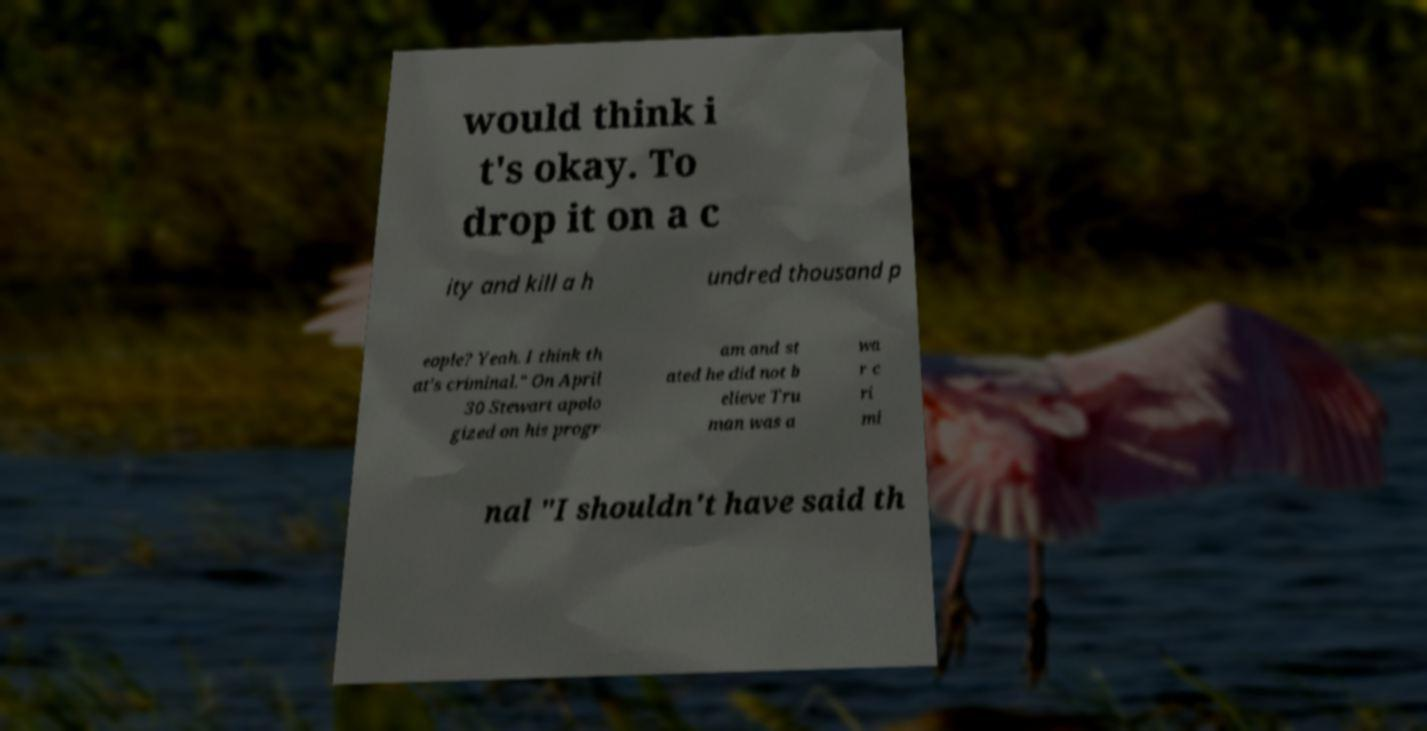Please identify and transcribe the text found in this image. would think i t's okay. To drop it on a c ity and kill a h undred thousand p eople? Yeah. I think th at's criminal." On April 30 Stewart apolo gized on his progr am and st ated he did not b elieve Tru man was a wa r c ri mi nal "I shouldn't have said th 